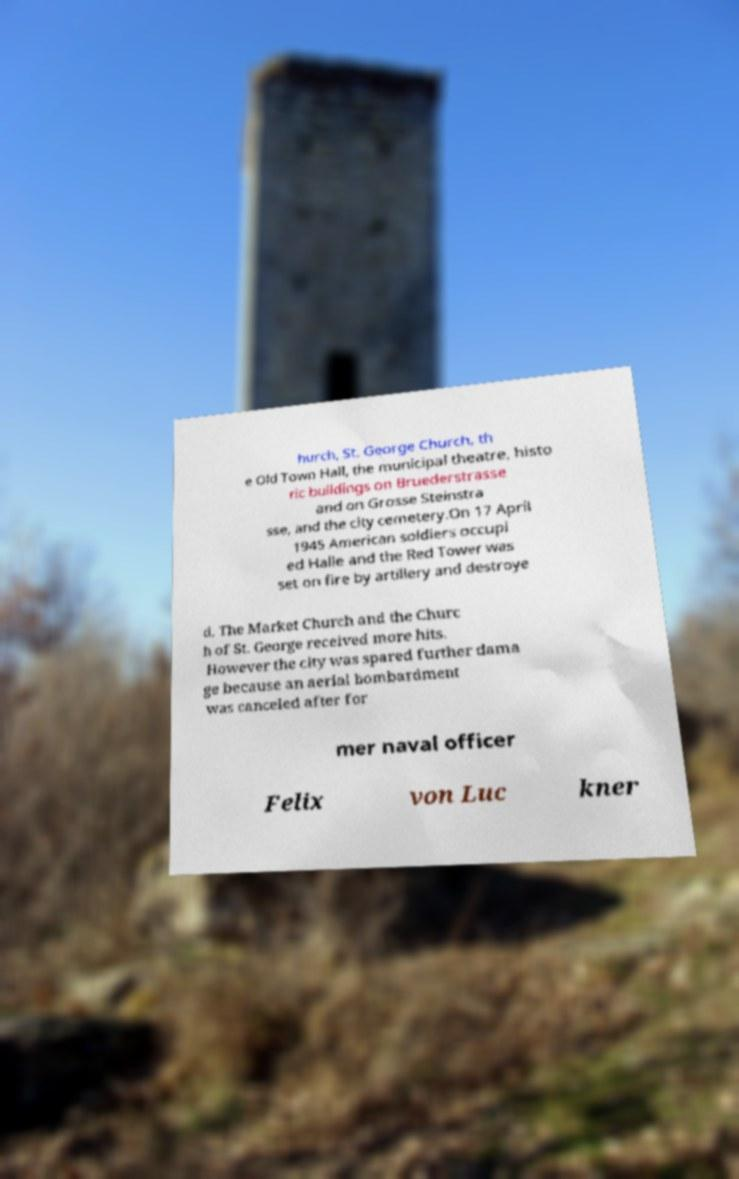Could you assist in decoding the text presented in this image and type it out clearly? hurch, St. George Church, th e Old Town Hall, the municipal theatre, histo ric buildings on Bruederstrasse and on Grosse Steinstra sse, and the city cemetery.On 17 April 1945 American soldiers occupi ed Halle and the Red Tower was set on fire by artillery and destroye d. The Market Church and the Churc h of St. George received more hits. However the city was spared further dama ge because an aerial bombardment was canceled after for mer naval officer Felix von Luc kner 